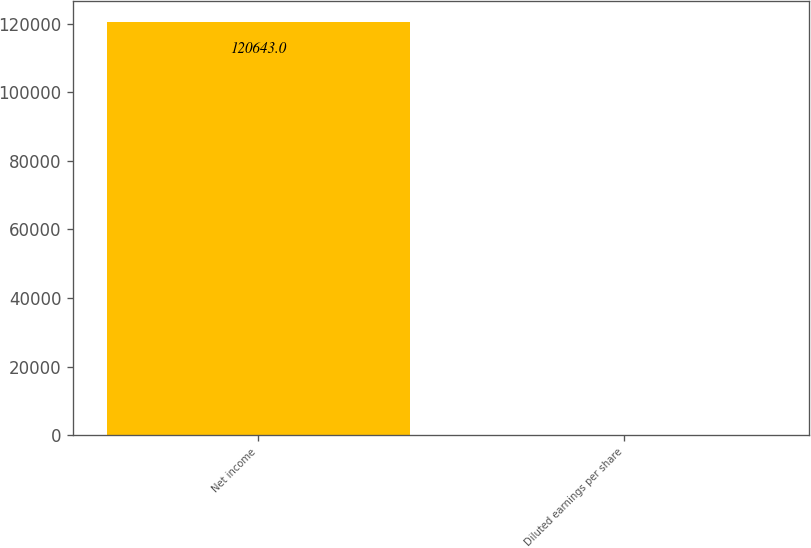Convert chart. <chart><loc_0><loc_0><loc_500><loc_500><bar_chart><fcel>Net income<fcel>Diluted earnings per share<nl><fcel>120643<fcel>1.66<nl></chart> 